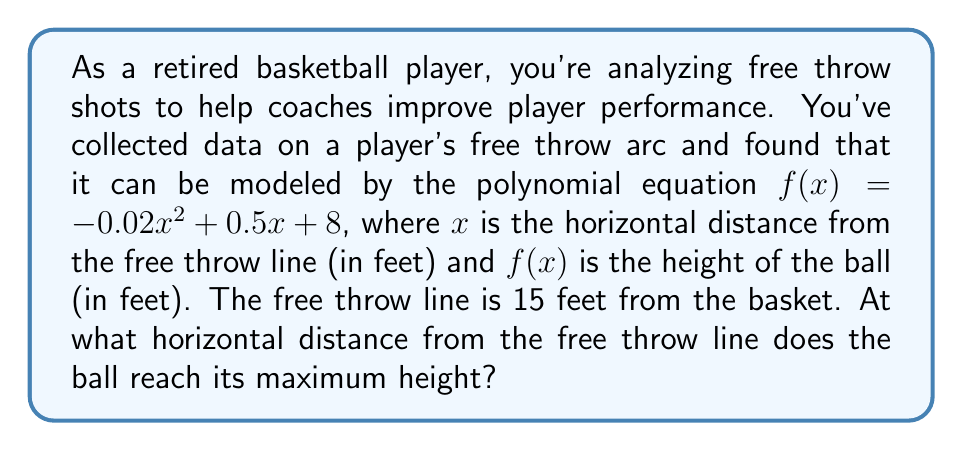What is the answer to this math problem? To find the maximum height of the ball's arc, we need to determine the vertex of the parabola described by the given quadratic function. Let's approach this step-by-step:

1) The general form of a quadratic function is $f(x) = ax^2 + bx + c$, where $a$, $b$, and $c$ are constants and $a \neq 0$.

2) In our case, $f(x) = -0.02x^2 + 0.5x + 8$, so $a = -0.02$, $b = 0.5$, and $c = 8$.

3) For a quadratic function, the x-coordinate of the vertex is given by the formula:

   $x = -\frac{b}{2a}$

4) Substituting our values:

   $x = -\frac{0.5}{2(-0.02)} = -\frac{0.5}{-0.04} = \frac{0.5}{0.04} = 12.5$

5) Therefore, the ball reaches its maximum height when $x = 12.5$ feet from the free throw line.

6) We can verify this by calculating the derivative of $f(x)$ and setting it to zero:

   $f'(x) = -0.04x + 0.5$
   $0 = -0.04x + 0.5$
   $0.04x = 0.5$
   $x = 12.5$

This confirms our result.
Answer: 12.5 feet 